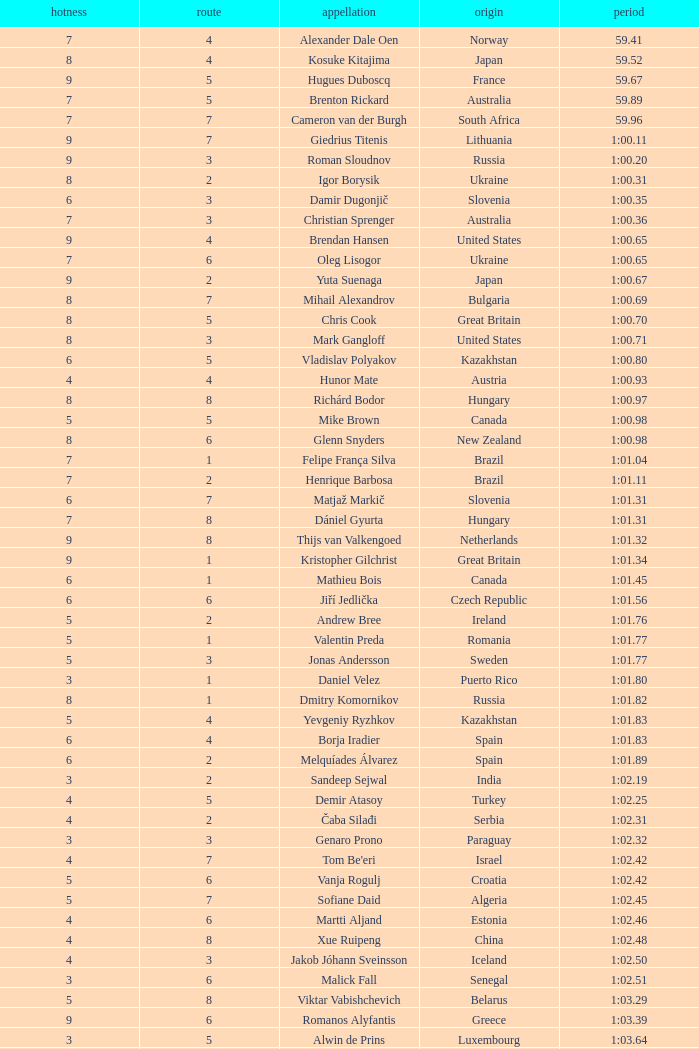What is the time in a heat smaller than 5, in Lane 5, for Vietnam? 1:06.36. 